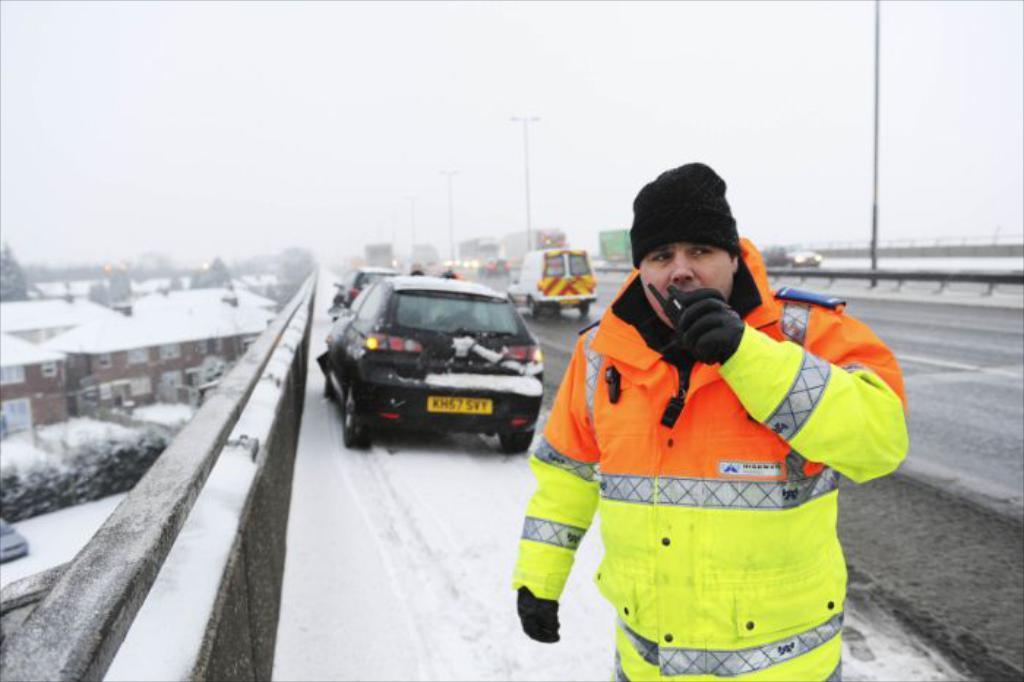Please provide a concise description of this image. In this image I can see a road in the centre and on it I can see a man is standing and behind him I can see number of vehicles and few poles. I can see he is wearing a jacket, gloves, a cap and I can also see a walkie talkie in his hand. On the left side of this image I can see a car, few trees and few buildings. I can also see snow on the road and on these buildings. 